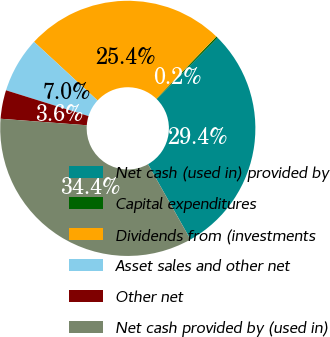Convert chart. <chart><loc_0><loc_0><loc_500><loc_500><pie_chart><fcel>Net cash (used in) provided by<fcel>Capital expenditures<fcel>Dividends from (investments<fcel>Asset sales and other net<fcel>Other net<fcel>Net cash provided by (used in)<nl><fcel>29.4%<fcel>0.21%<fcel>25.35%<fcel>7.04%<fcel>3.62%<fcel>34.37%<nl></chart> 